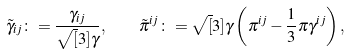Convert formula to latex. <formula><loc_0><loc_0><loc_500><loc_500>\tilde { \gamma } _ { i j } \colon = \frac { \gamma _ { i j } } { \sqrt { [ } 3 ] { \gamma } } , \quad \tilde { \pi } ^ { i j } \colon = \sqrt { [ } 3 ] { \gamma } \left ( \pi ^ { i j } - \frac { 1 } { 3 } \pi \gamma ^ { i j } \right ) ,</formula> 